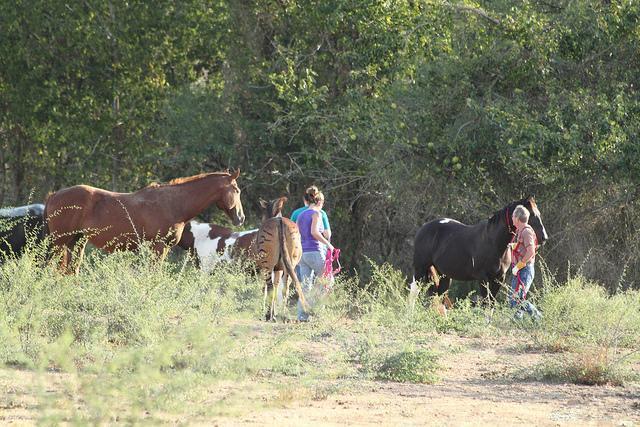How many horses are there?
Give a very brief answer. 2. How many people can be seen?
Give a very brief answer. 2. 